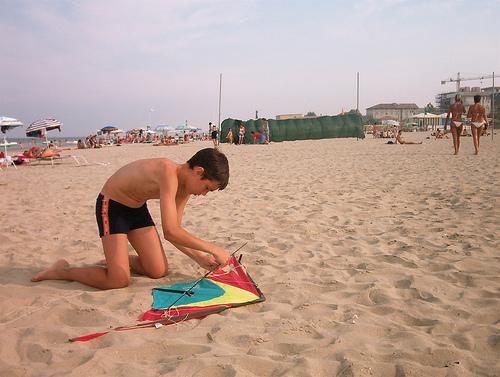What are people doing?
Concise answer only. Flying kites. Is in a nude beach?
Short answer required. No. What is set up on the beach to provide shade?
Quick response, please. Umbrellas. What is the color of the sky?
Keep it brief. Blue. What color is the largest item in the background?
Concise answer only. Green. 